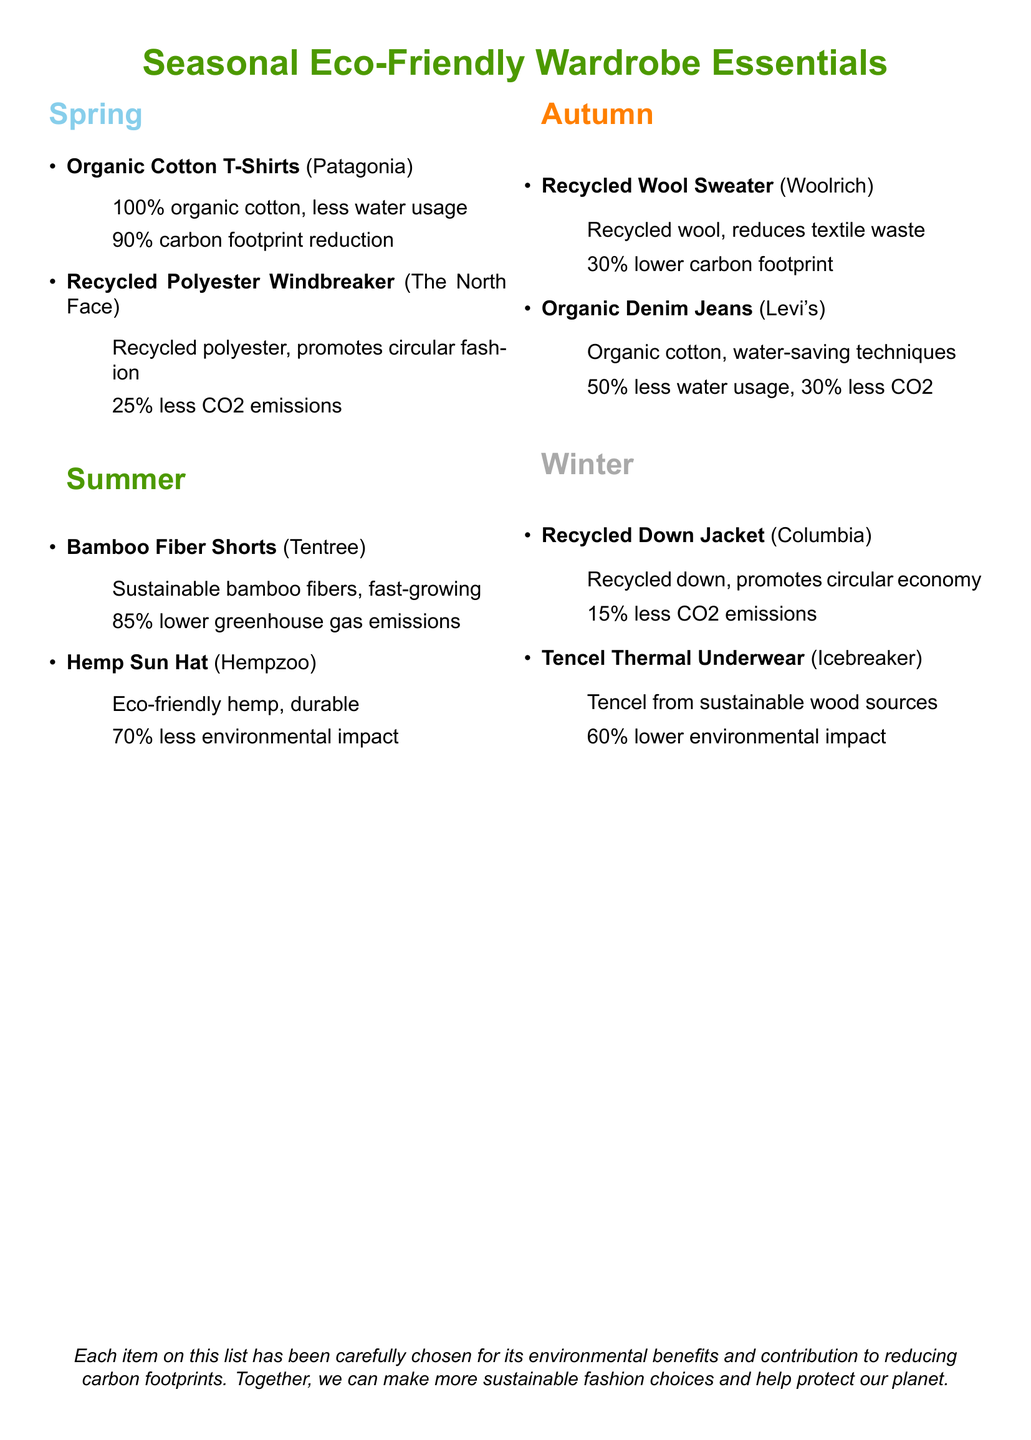What item is listed for spring? The document lists "Organic Cotton T-Shirts" and "Recycled Polyester Windbreaker" as items for spring.
Answer: Organic Cotton T-Shirts What is the carbon footprint reduction percentage for organic cotton t-shirts? The document states that organic cotton t-shirts have a 90% carbon footprint reduction.
Answer: 90% Which summer item is made from fast-growing material? "Bamboo Fiber Shorts," made from sustainable bamboo fibers, is mentioned as fast-growing.
Answer: Bamboo Fiber Shorts What is the winter item made from recycled materials? The "Recycled Down Jacket" is the winter item made from recycled materials.
Answer: Recycled Down Jacket What percentage of lower emissions is associated with the Hemp Sun Hat? The document indicates that the Hemp Sun Hat has a 70% less environmental impact.
Answer: 70% How much lower is the greenhouse gas emissions for bamboo fiber shorts? The emissions for bamboo fiber shorts are 85% lower according to the document.
Answer: 85% What technique do organic denim jeans use to save water? The document mentions they use "water-saving techniques."
Answer: water-saving techniques What is the main environmental benefit mentioned for the Recycled Wool Sweater? The main benefit noted is that it reduces textile waste.
Answer: reduces textile waste What brand produces the Tencel Thermal Underwear? The Tencel Thermal Underwear is produced by Icebreaker.
Answer: Icebreaker 